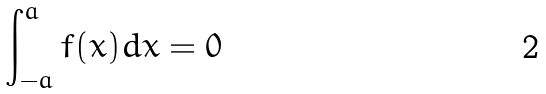Convert formula to latex. <formula><loc_0><loc_0><loc_500><loc_500>\int _ { - a } ^ { a } f ( x ) d x = 0</formula> 